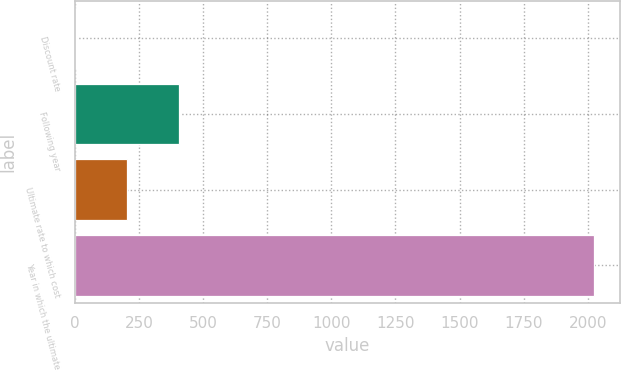<chart> <loc_0><loc_0><loc_500><loc_500><bar_chart><fcel>Discount rate<fcel>Following year<fcel>Ultimate rate to which cost<fcel>Year in which the ultimate<nl><fcel>3.2<fcel>407.16<fcel>205.18<fcel>2023<nl></chart> 